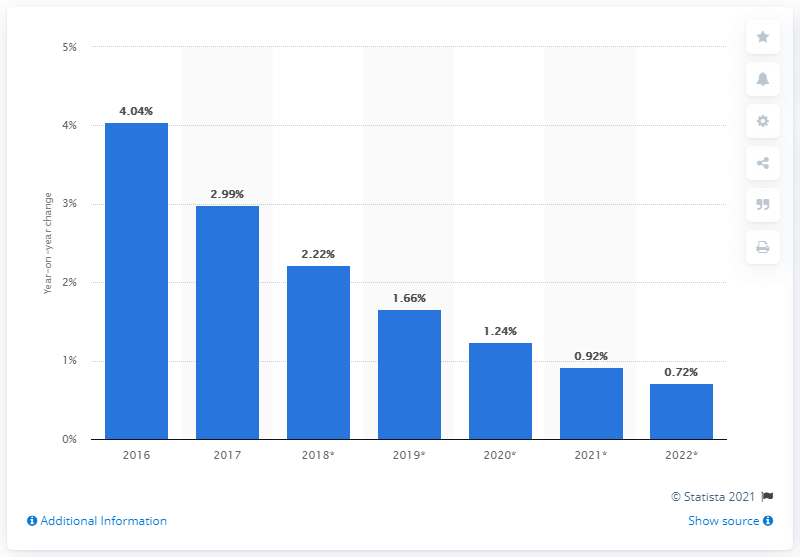Draw attention to some important aspects in this diagram. The number of mobile phone internet users increased by 2.99% in 2017. 